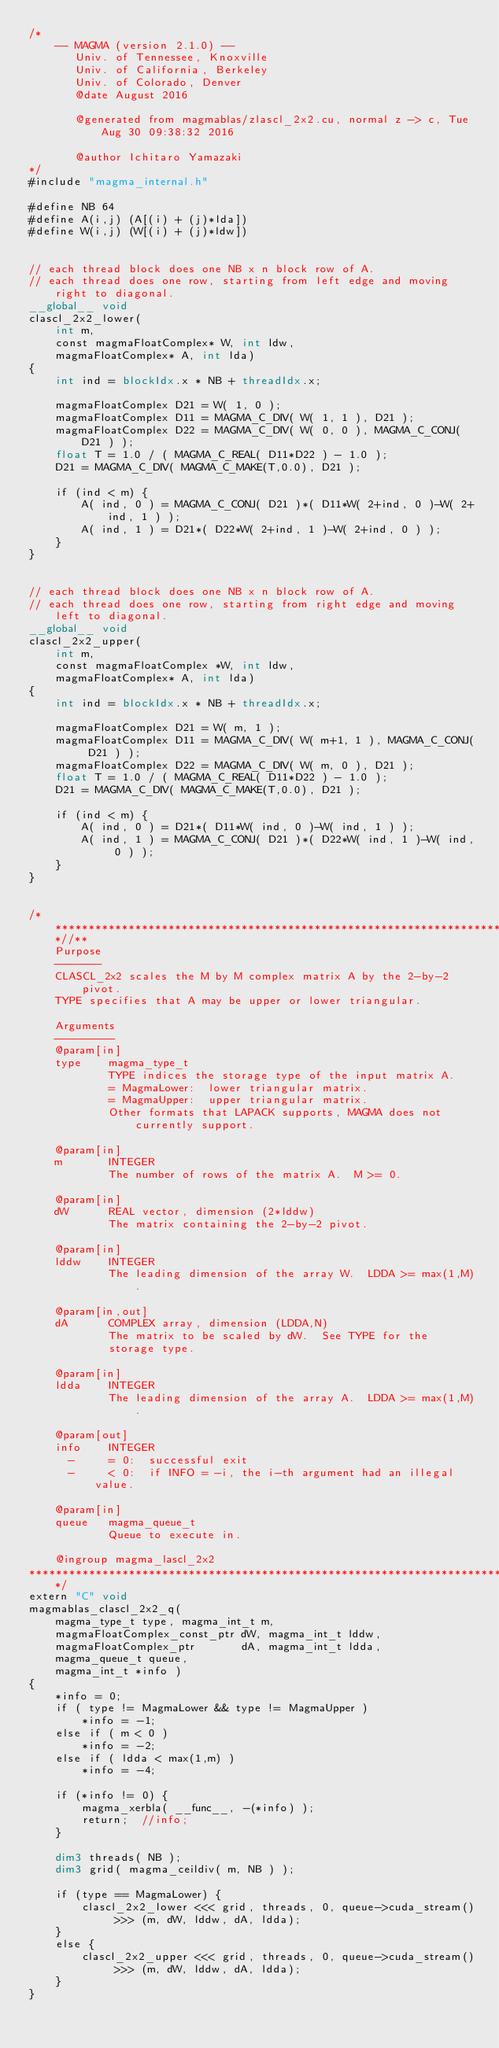Convert code to text. <code><loc_0><loc_0><loc_500><loc_500><_Cuda_>/*
    -- MAGMA (version 2.1.0) --
       Univ. of Tennessee, Knoxville
       Univ. of California, Berkeley
       Univ. of Colorado, Denver
       @date August 2016

       @generated from magmablas/zlascl_2x2.cu, normal z -> c, Tue Aug 30 09:38:32 2016

       @author Ichitaro Yamazaki
*/
#include "magma_internal.h"

#define NB 64
#define A(i,j) (A[(i) + (j)*lda])
#define W(i,j) (W[(i) + (j)*ldw])


// each thread block does one NB x n block row of A.
// each thread does one row, starting from left edge and moving right to diagonal.
__global__ void
clascl_2x2_lower(
    int m,
    const magmaFloatComplex* W, int ldw,
    magmaFloatComplex* A, int lda)
{
    int ind = blockIdx.x * NB + threadIdx.x;

    magmaFloatComplex D21 = W( 1, 0 );
    magmaFloatComplex D11 = MAGMA_C_DIV( W( 1, 1 ), D21 );
    magmaFloatComplex D22 = MAGMA_C_DIV( W( 0, 0 ), MAGMA_C_CONJ( D21 ) );
    float T = 1.0 / ( MAGMA_C_REAL( D11*D22 ) - 1.0 );
    D21 = MAGMA_C_DIV( MAGMA_C_MAKE(T,0.0), D21 );

    if (ind < m) {
        A( ind, 0 ) = MAGMA_C_CONJ( D21 )*( D11*W( 2+ind, 0 )-W( 2+ind, 1 ) );
        A( ind, 1 ) = D21*( D22*W( 2+ind, 1 )-W( 2+ind, 0 ) );
    }
}


// each thread block does one NB x n block row of A.
// each thread does one row, starting from right edge and moving left to diagonal.
__global__ void
clascl_2x2_upper(
    int m,
    const magmaFloatComplex *W, int ldw,
    magmaFloatComplex* A, int lda)
{
    int ind = blockIdx.x * NB + threadIdx.x;

    magmaFloatComplex D21 = W( m, 1 );
    magmaFloatComplex D11 = MAGMA_C_DIV( W( m+1, 1 ), MAGMA_C_CONJ( D21 ) );
    magmaFloatComplex D22 = MAGMA_C_DIV( W( m, 0 ), D21 );
    float T = 1.0 / ( MAGMA_C_REAL( D11*D22 ) - 1.0 );
    D21 = MAGMA_C_DIV( MAGMA_C_MAKE(T,0.0), D21 );

    if (ind < m) {
        A( ind, 0 ) = D21*( D11*W( ind, 0 )-W( ind, 1 ) );
        A( ind, 1 ) = MAGMA_C_CONJ( D21 )*( D22*W( ind, 1 )-W( ind, 0 ) );
    }
}


/***************************************************************************//**
    Purpose
    -------
    CLASCL_2x2 scales the M by M complex matrix A by the 2-by-2 pivot.
    TYPE specifies that A may be upper or lower triangular.

    Arguments
    ---------
    @param[in]
    type    magma_type_t
            TYPE indices the storage type of the input matrix A.
            = MagmaLower:  lower triangular matrix.
            = MagmaUpper:  upper triangular matrix.
            Other formats that LAPACK supports, MAGMA does not currently support.

    @param[in]
    m       INTEGER
            The number of rows of the matrix A.  M >= 0.

    @param[in]
    dW      REAL vector, dimension (2*lddw)
            The matrix containing the 2-by-2 pivot.

    @param[in]
    lddw    INTEGER
            The leading dimension of the array W.  LDDA >= max(1,M).

    @param[in,out]
    dA      COMPLEX array, dimension (LDDA,N)
            The matrix to be scaled by dW.  See TYPE for the
            storage type.

    @param[in]
    ldda    INTEGER
            The leading dimension of the array A.  LDDA >= max(1,M).

    @param[out]
    info    INTEGER
      -     = 0:  successful exit
      -     < 0:  if INFO = -i, the i-th argument had an illegal value.

    @param[in]
    queue   magma_queue_t
            Queue to execute in.

    @ingroup magma_lascl_2x2
*******************************************************************************/
extern "C" void
magmablas_clascl_2x2_q(
    magma_type_t type, magma_int_t m,
    magmaFloatComplex_const_ptr dW, magma_int_t lddw,
    magmaFloatComplex_ptr       dA, magma_int_t ldda,
    magma_queue_t queue,
    magma_int_t *info )
{
    *info = 0;
    if ( type != MagmaLower && type != MagmaUpper )
        *info = -1;
    else if ( m < 0 )
        *info = -2;
    else if ( ldda < max(1,m) )
        *info = -4;
    
    if (*info != 0) {
        magma_xerbla( __func__, -(*info) );
        return;  //info;
    }
    
    dim3 threads( NB );
    dim3 grid( magma_ceildiv( m, NB ) );
    
    if (type == MagmaLower) {
        clascl_2x2_lower <<< grid, threads, 0, queue->cuda_stream() >>> (m, dW, lddw, dA, ldda);
    }
    else {
        clascl_2x2_upper <<< grid, threads, 0, queue->cuda_stream() >>> (m, dW, lddw, dA, ldda);
    }
}
</code> 